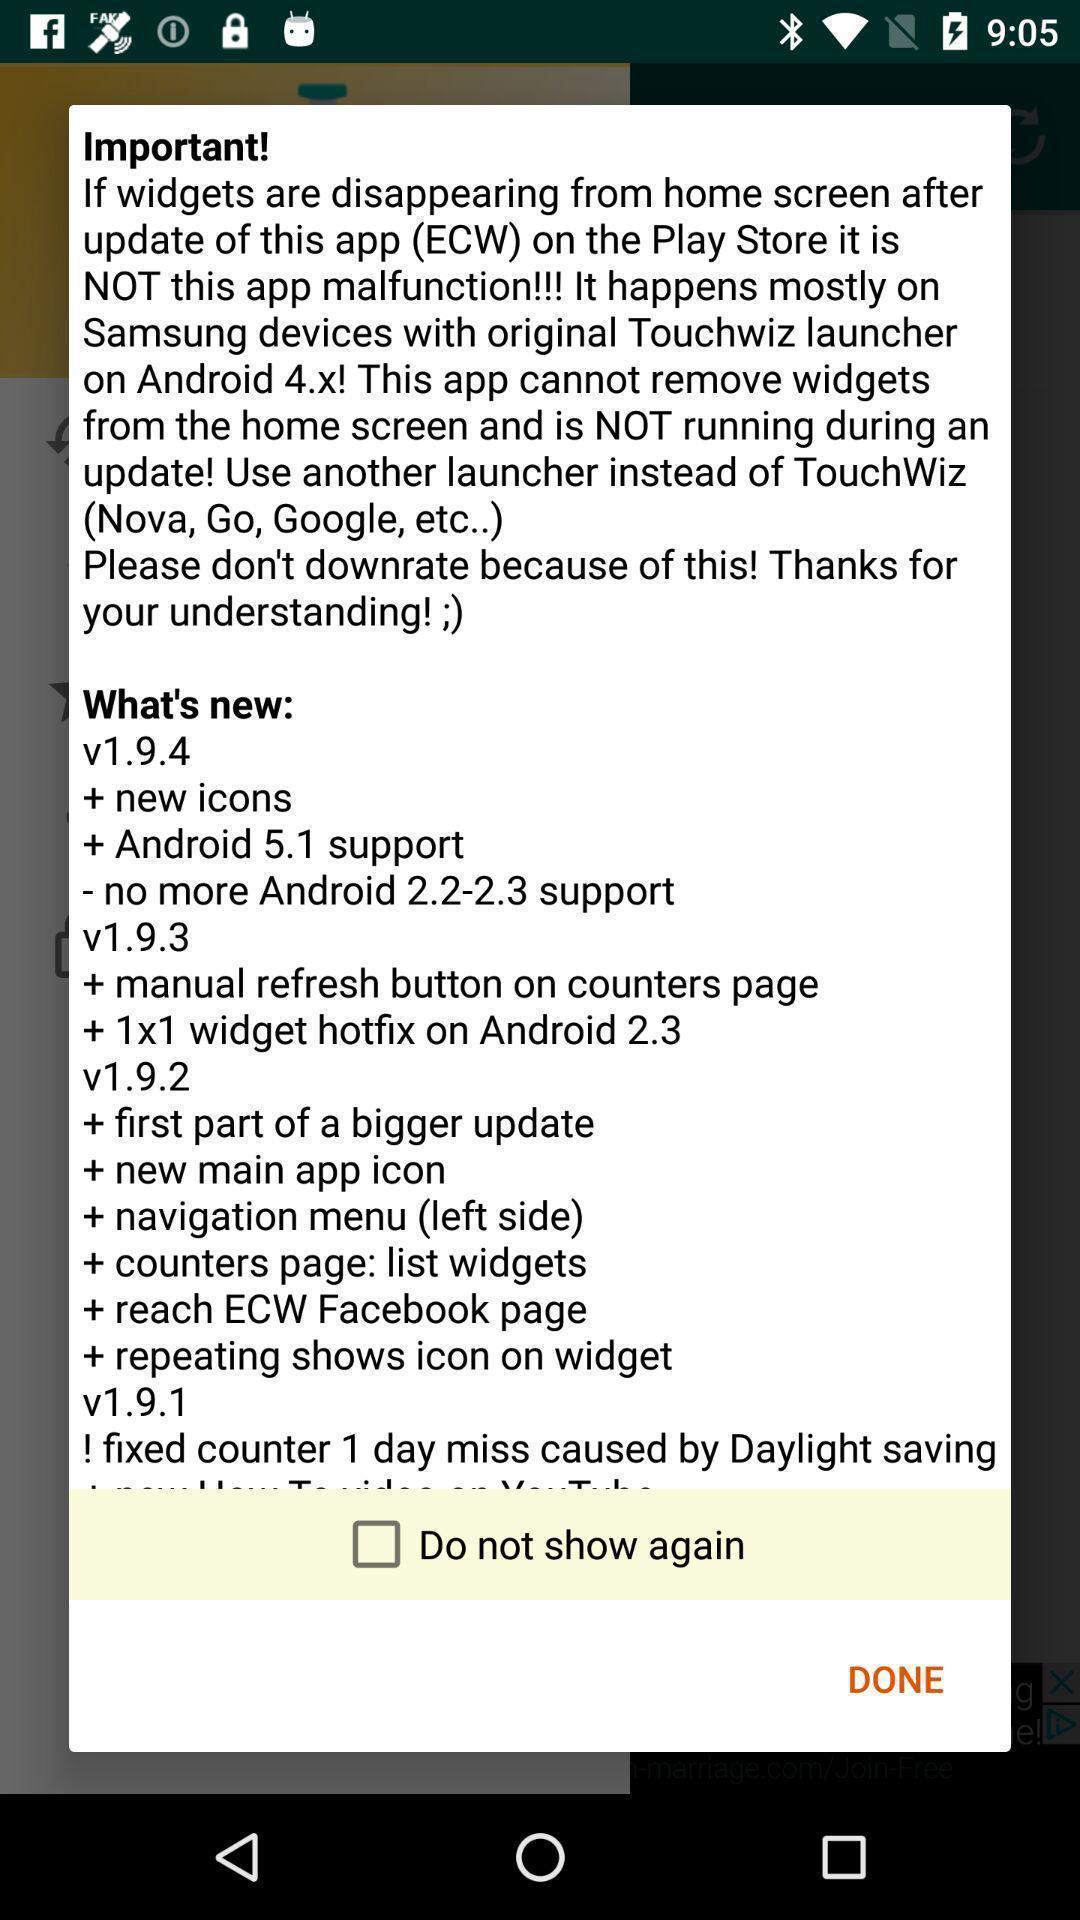Give me a summary of this screen capture. Pop-up with info in a date organizer app. 